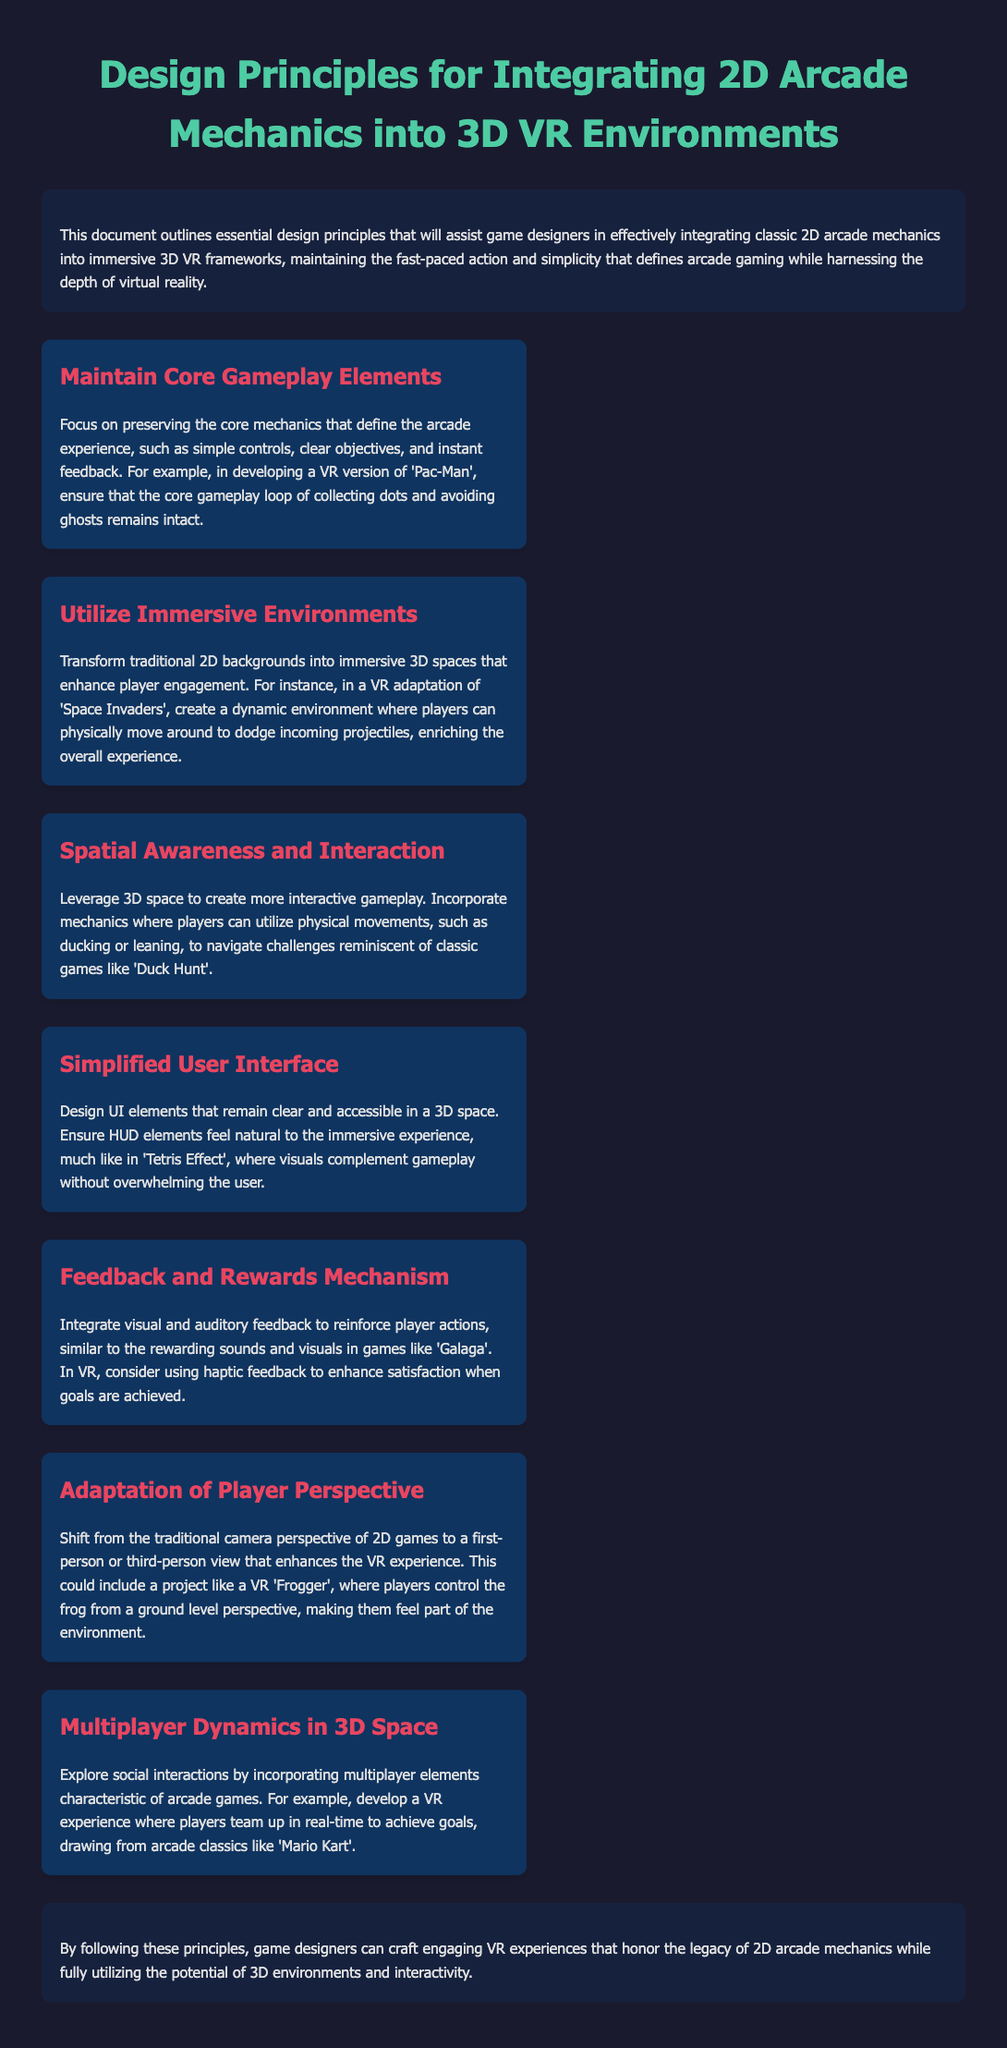what is the title of the document? The title of the document is provided at the top of the rendered page, indicating its main focus.
Answer: Design Principles for Integrating 2D Arcade Mechanics into 3D VR Environments how many design principles are listed? The document provides a specific count of the design principles included within it.
Answer: seven name one game mentioned as an example for maintaining core gameplay elements. An example game is given to illustrate the principle of maintaining core gameplay, showcasing a specific case.
Answer: Pac-Man what is emphasized in the principle of utilizing immersive environments? This principle discusses the transformation of a specific aspect of game design to enhance player engagement.
Answer: dynamic environment how should user interface elements be designed according to the document? The document outlines a particular approach to designing UI elements in relation to VR experiences.
Answer: clear and accessible which perspective is suggested for adaptation of player perspective? The document recommends a shift from a traditional visual perspective to a more immersive one.
Answer: first-person or third-person view what aspect does the principle of feedback and rewards mechanism focus on? This principle highlights a crucial feature of gameplay that enhances player satisfaction through various means.
Answer: visual and auditory feedback what is the main objective of following these design principles? The conclusion specifies the overarching goal that designers aim to achieve by adhering to the principles outlined.
Answer: craft engaging VR experiences 